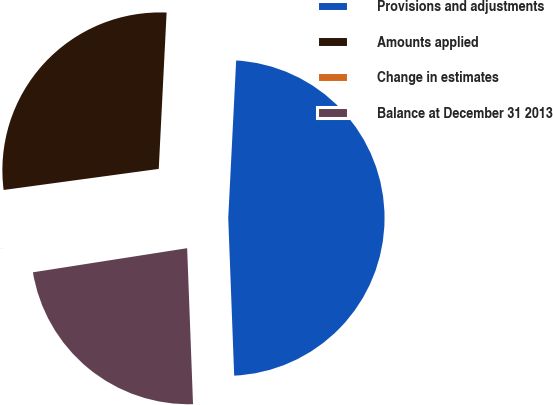<chart> <loc_0><loc_0><loc_500><loc_500><pie_chart><fcel>Provisions and adjustments<fcel>Amounts applied<fcel>Change in estimates<fcel>Balance at December 31 2013<nl><fcel>48.6%<fcel>27.95%<fcel>0.32%<fcel>23.13%<nl></chart> 